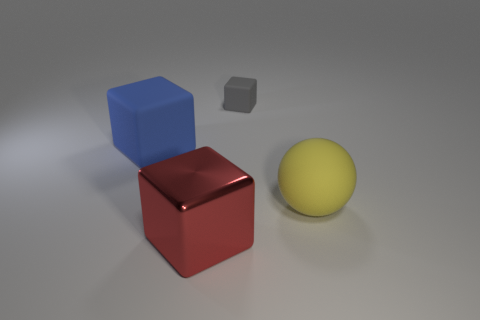How does lighting affect the appearance of these objects? The lighting in the image creates soft shadows and subtle reflections on the surfaces of the objects. It highlights the texture differences, such as the matte finish of the gray cube, versus the shiny surface of the red cube. This contrasting interplay between light and texture adds depth and realism to the scene. 